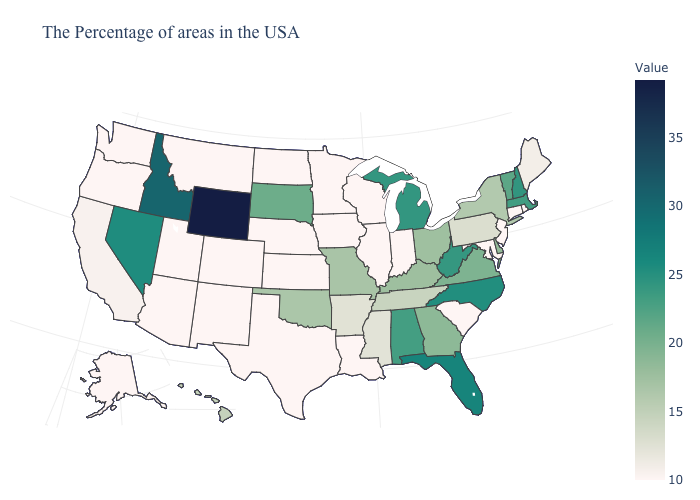Which states have the highest value in the USA?
Short answer required. Wyoming. Among the states that border New York , which have the lowest value?
Keep it brief. Connecticut, New Jersey. Among the states that border Oklahoma , which have the highest value?
Give a very brief answer. Missouri. Does Louisiana have the lowest value in the South?
Quick response, please. Yes. 